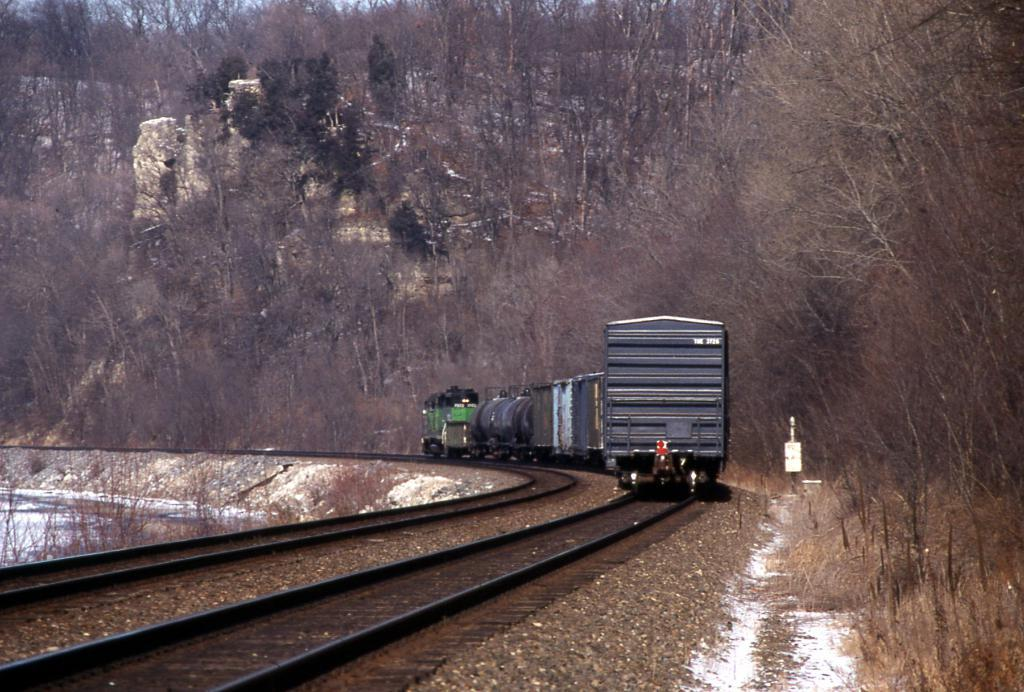What is the main subject of the image? The main subject of the image is a train. What is the train's position in relation to the tracks? The train is on tracks in the image. What type of vegetation is visible near the train? There are trees beside the train. What additional object can be seen in the image? There is a box in the image. Can you see the vein in the throat of the train conductor in the image? There is no train conductor present in the image, and therefore no vein or throat can be observed. 